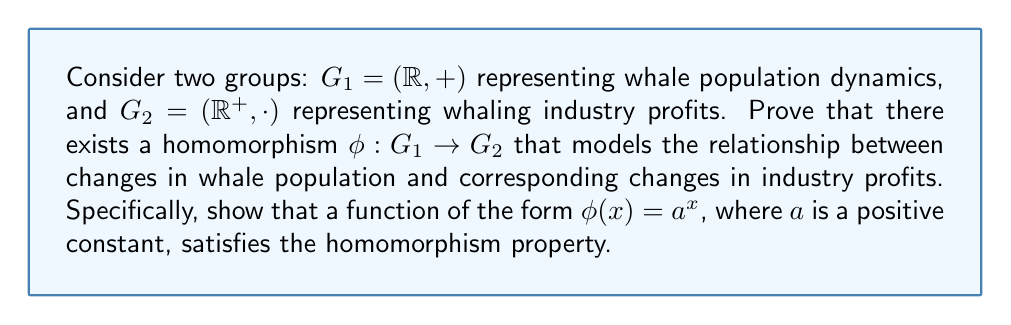Provide a solution to this math problem. To prove the existence of a homomorphism between the two groups, we need to show that the function $\phi(x) = a^x$ satisfies the homomorphism property. For a function to be a homomorphism, it must preserve the group operation. In this case, we need to prove that:

$$\phi(x + y) = \phi(x) \cdot \phi(y)$$

Let's proceed step by step:

1) First, let's consider the left side of the equation:
   $$\phi(x + y) = a^{x+y}$$

2) Now, let's consider the right side of the equation:
   $$\phi(x) \cdot \phi(y) = a^x \cdot a^y$$

3) Using the laws of exponents, we know that:
   $$a^x \cdot a^y = a^{x+y}$$

4) Therefore, we can see that:
   $$\phi(x + y) = a^{x+y} = a^x \cdot a^y = \phi(x) \cdot \phi(y)$$

5) This proves that $\phi(x) = a^x$ satisfies the homomorphism property.

In the context of whale population dynamics and whaling industry profits:
- $x$ in $G_1$ represents a change in whale population
- $\phi(x)$ in $G_2$ represents the corresponding change in industry profits
- The constant $a$ represents the base rate of change in profits relative to population change

If $a > 1$, it indicates that profits increase as whale population increases (e.g., in a sustainable whaling model or whale-watching industry). If $0 < a < 1$, it suggests that profits decrease as whale population increases (e.g., in an overfishing scenario where increased competition leads to lower profits).
Answer: The function $\phi(x) = a^x$, where $a$ is a positive constant, is a homomorphism from $G_1 = (\mathbb{R}, +)$ to $G_2 = (\mathbb{R}^+, \cdot)$, as it satisfies the homomorphism property $\phi(x + y) = \phi(x) \cdot \phi(y)$ for all $x, y \in \mathbb{R}$. 